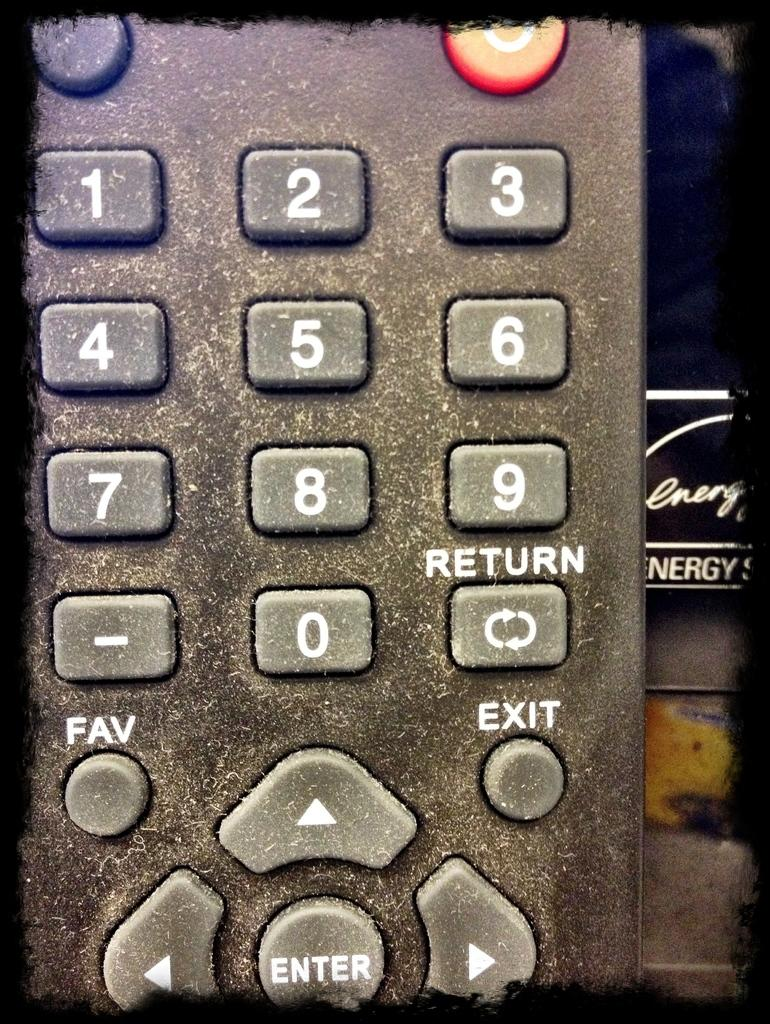Provide a one-sentence caption for the provided image. A dusty remote control is held in front of some literature on energy. 